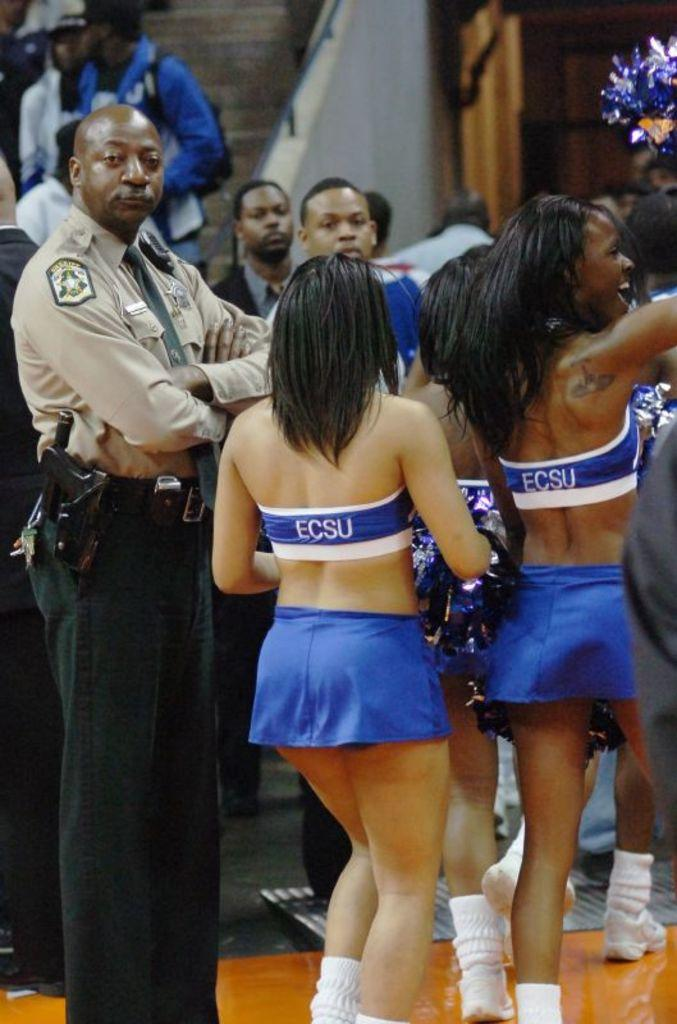<image>
Give a short and clear explanation of the subsequent image. Three cheerleaders for ESCU are walking past a police officer, off a basketball court cheering. 